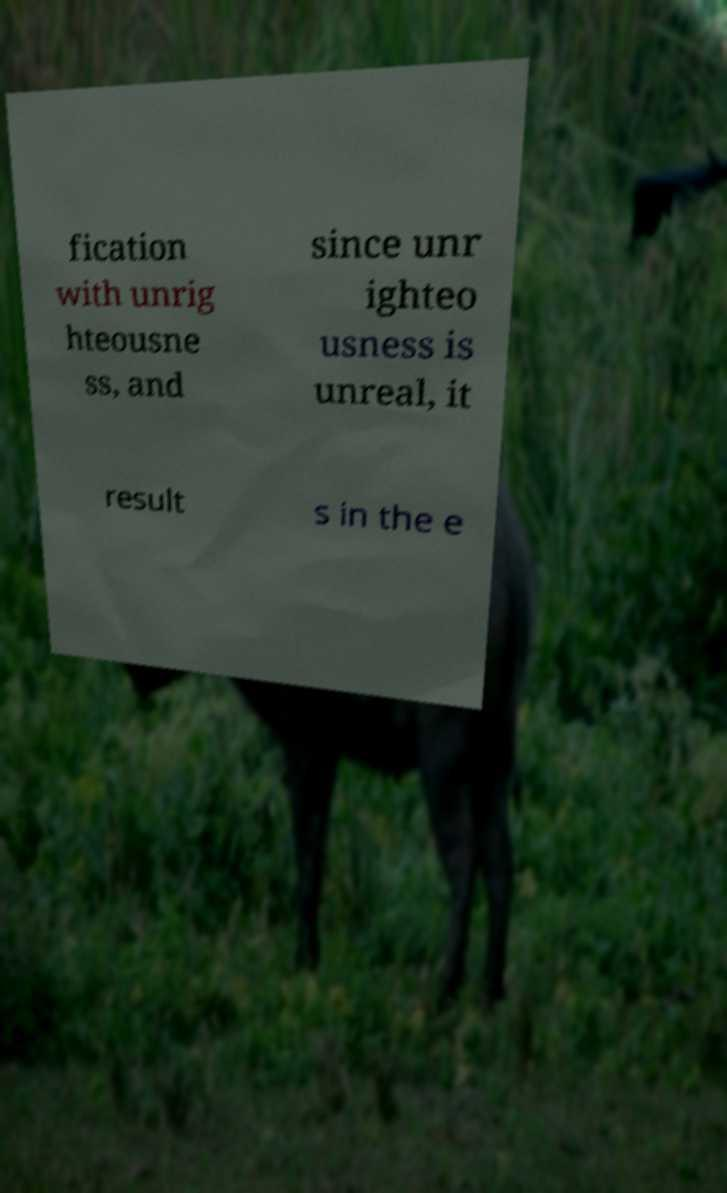Could you assist in decoding the text presented in this image and type it out clearly? fication with unrig hteousne ss, and since unr ighteo usness is unreal, it result s in the e 